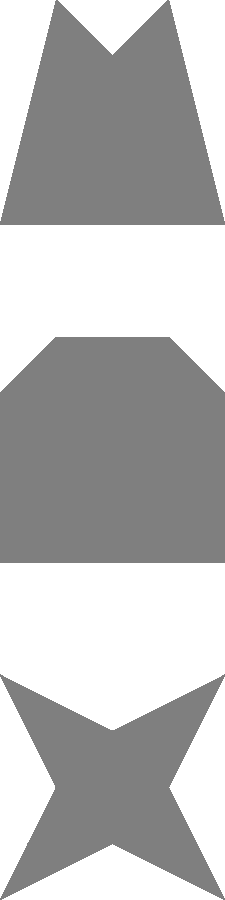Your child is playing an educational game that involves matching animal silhouettes to their corresponding shadows. Can you help them identify which shadow (1, 2, or 3) matches the giraffe silhouette (A, B, or C)? Let's approach this step-by-step:

1. First, we need to identify the giraffe silhouette among A, B, and C:
   - A appears to be a lion with its distinctive mane.
   - B looks like an elephant with its trunk and large body.
   - C has a long neck and legs, characteristic of a giraffe.
   So, the giraffe silhouette is C.

2. Now, we need to match the giraffe silhouette (C) to its shadow:
   - Shadow 1 has a shape similar to the lion silhouette (A).
   - Shadow 2 has a bulky body and a trunk-like projection, matching the elephant silhouette (B).
   - Shadow 3 has a long neck and legs, corresponding to the giraffe silhouette (C).

3. Therefore, the shadow that matches the giraffe silhouette is number 3.

This puzzle helps children develop visual perception skills and learn about animal shapes, making learning engaging and fun.
Answer: 3 